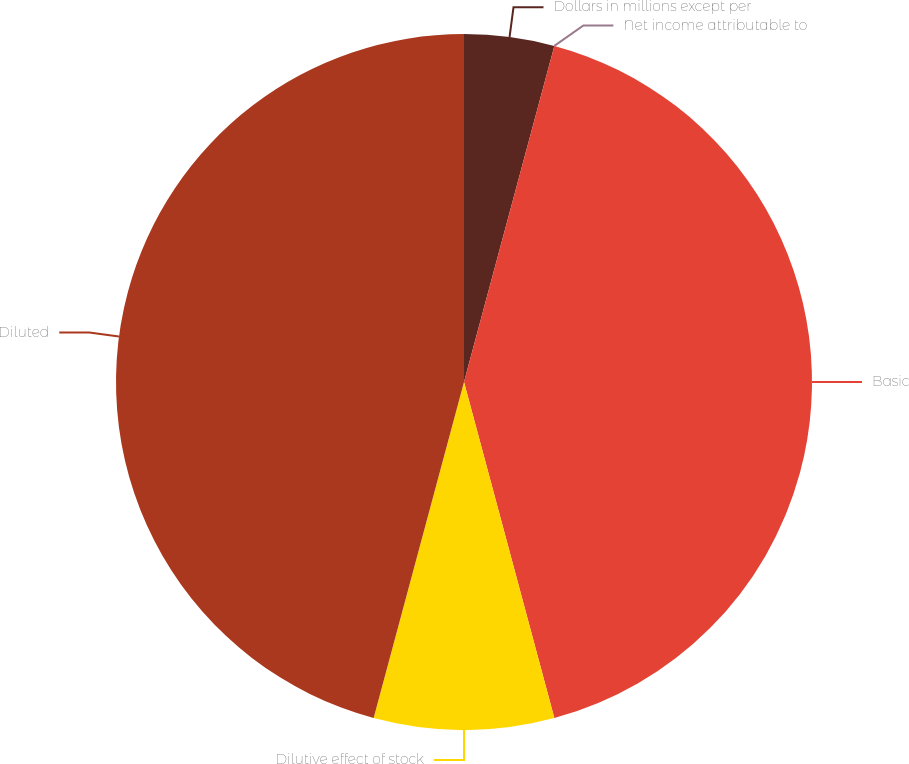<chart> <loc_0><loc_0><loc_500><loc_500><pie_chart><fcel>Dollars in millions except per<fcel>Net income attributable to<fcel>Basic<fcel>Dilutive effect of stock<fcel>Diluted<nl><fcel>4.18%<fcel>0.0%<fcel>41.64%<fcel>8.36%<fcel>45.82%<nl></chart> 